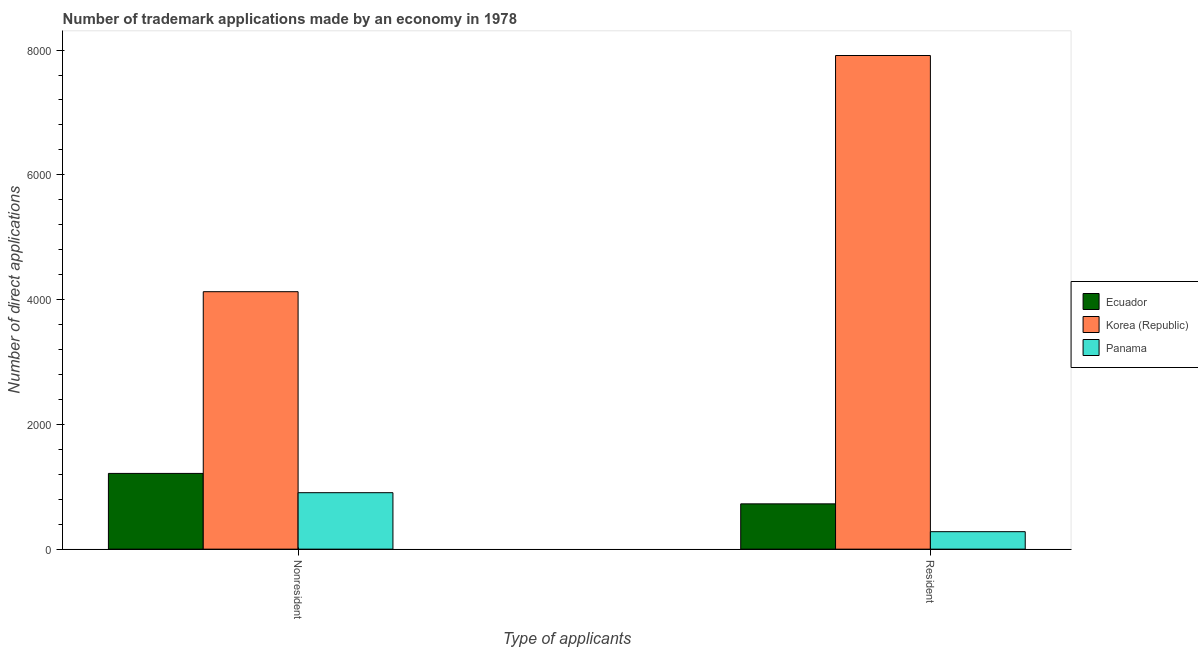How many groups of bars are there?
Make the answer very short. 2. How many bars are there on the 2nd tick from the left?
Provide a short and direct response. 3. How many bars are there on the 1st tick from the right?
Provide a short and direct response. 3. What is the label of the 2nd group of bars from the left?
Your answer should be very brief. Resident. What is the number of trademark applications made by non residents in Korea (Republic)?
Your answer should be compact. 4127. Across all countries, what is the maximum number of trademark applications made by non residents?
Offer a terse response. 4127. Across all countries, what is the minimum number of trademark applications made by non residents?
Offer a terse response. 905. In which country was the number of trademark applications made by non residents maximum?
Ensure brevity in your answer.  Korea (Republic). In which country was the number of trademark applications made by non residents minimum?
Make the answer very short. Panama. What is the total number of trademark applications made by non residents in the graph?
Provide a short and direct response. 6246. What is the difference between the number of trademark applications made by residents in Panama and that in Korea (Republic)?
Offer a terse response. -7633. What is the difference between the number of trademark applications made by residents in Ecuador and the number of trademark applications made by non residents in Panama?
Make the answer very short. -179. What is the average number of trademark applications made by residents per country?
Keep it short and to the point. 2973. What is the difference between the number of trademark applications made by residents and number of trademark applications made by non residents in Panama?
Make the answer very short. -625. What is the ratio of the number of trademark applications made by non residents in Korea (Republic) to that in Panama?
Give a very brief answer. 4.56. Is the number of trademark applications made by residents in Panama less than that in Ecuador?
Offer a very short reply. Yes. In how many countries, is the number of trademark applications made by residents greater than the average number of trademark applications made by residents taken over all countries?
Provide a short and direct response. 1. What does the 1st bar from the left in Nonresident represents?
Make the answer very short. Ecuador. How many bars are there?
Provide a succinct answer. 6. Are all the bars in the graph horizontal?
Offer a terse response. No. How many countries are there in the graph?
Provide a succinct answer. 3. Where does the legend appear in the graph?
Your answer should be compact. Center right. What is the title of the graph?
Provide a succinct answer. Number of trademark applications made by an economy in 1978. Does "Luxembourg" appear as one of the legend labels in the graph?
Your answer should be very brief. No. What is the label or title of the X-axis?
Your response must be concise. Type of applicants. What is the label or title of the Y-axis?
Ensure brevity in your answer.  Number of direct applications. What is the Number of direct applications of Ecuador in Nonresident?
Ensure brevity in your answer.  1214. What is the Number of direct applications of Korea (Republic) in Nonresident?
Provide a succinct answer. 4127. What is the Number of direct applications of Panama in Nonresident?
Your response must be concise. 905. What is the Number of direct applications in Ecuador in Resident?
Your answer should be compact. 726. What is the Number of direct applications in Korea (Republic) in Resident?
Your answer should be compact. 7913. What is the Number of direct applications in Panama in Resident?
Give a very brief answer. 280. Across all Type of applicants, what is the maximum Number of direct applications of Ecuador?
Offer a terse response. 1214. Across all Type of applicants, what is the maximum Number of direct applications of Korea (Republic)?
Keep it short and to the point. 7913. Across all Type of applicants, what is the maximum Number of direct applications in Panama?
Your answer should be very brief. 905. Across all Type of applicants, what is the minimum Number of direct applications in Ecuador?
Make the answer very short. 726. Across all Type of applicants, what is the minimum Number of direct applications of Korea (Republic)?
Give a very brief answer. 4127. Across all Type of applicants, what is the minimum Number of direct applications in Panama?
Offer a very short reply. 280. What is the total Number of direct applications in Ecuador in the graph?
Keep it short and to the point. 1940. What is the total Number of direct applications of Korea (Republic) in the graph?
Offer a very short reply. 1.20e+04. What is the total Number of direct applications of Panama in the graph?
Provide a succinct answer. 1185. What is the difference between the Number of direct applications in Ecuador in Nonresident and that in Resident?
Your answer should be compact. 488. What is the difference between the Number of direct applications of Korea (Republic) in Nonresident and that in Resident?
Your response must be concise. -3786. What is the difference between the Number of direct applications in Panama in Nonresident and that in Resident?
Give a very brief answer. 625. What is the difference between the Number of direct applications of Ecuador in Nonresident and the Number of direct applications of Korea (Republic) in Resident?
Keep it short and to the point. -6699. What is the difference between the Number of direct applications of Ecuador in Nonresident and the Number of direct applications of Panama in Resident?
Ensure brevity in your answer.  934. What is the difference between the Number of direct applications of Korea (Republic) in Nonresident and the Number of direct applications of Panama in Resident?
Provide a succinct answer. 3847. What is the average Number of direct applications in Ecuador per Type of applicants?
Your answer should be compact. 970. What is the average Number of direct applications in Korea (Republic) per Type of applicants?
Offer a very short reply. 6020. What is the average Number of direct applications in Panama per Type of applicants?
Your response must be concise. 592.5. What is the difference between the Number of direct applications in Ecuador and Number of direct applications in Korea (Republic) in Nonresident?
Make the answer very short. -2913. What is the difference between the Number of direct applications of Ecuador and Number of direct applications of Panama in Nonresident?
Give a very brief answer. 309. What is the difference between the Number of direct applications of Korea (Republic) and Number of direct applications of Panama in Nonresident?
Your response must be concise. 3222. What is the difference between the Number of direct applications in Ecuador and Number of direct applications in Korea (Republic) in Resident?
Your response must be concise. -7187. What is the difference between the Number of direct applications in Ecuador and Number of direct applications in Panama in Resident?
Your answer should be compact. 446. What is the difference between the Number of direct applications in Korea (Republic) and Number of direct applications in Panama in Resident?
Offer a very short reply. 7633. What is the ratio of the Number of direct applications in Ecuador in Nonresident to that in Resident?
Your response must be concise. 1.67. What is the ratio of the Number of direct applications of Korea (Republic) in Nonresident to that in Resident?
Give a very brief answer. 0.52. What is the ratio of the Number of direct applications of Panama in Nonresident to that in Resident?
Offer a terse response. 3.23. What is the difference between the highest and the second highest Number of direct applications of Ecuador?
Offer a terse response. 488. What is the difference between the highest and the second highest Number of direct applications in Korea (Republic)?
Your answer should be very brief. 3786. What is the difference between the highest and the second highest Number of direct applications of Panama?
Your answer should be compact. 625. What is the difference between the highest and the lowest Number of direct applications in Ecuador?
Provide a succinct answer. 488. What is the difference between the highest and the lowest Number of direct applications of Korea (Republic)?
Make the answer very short. 3786. What is the difference between the highest and the lowest Number of direct applications in Panama?
Offer a terse response. 625. 